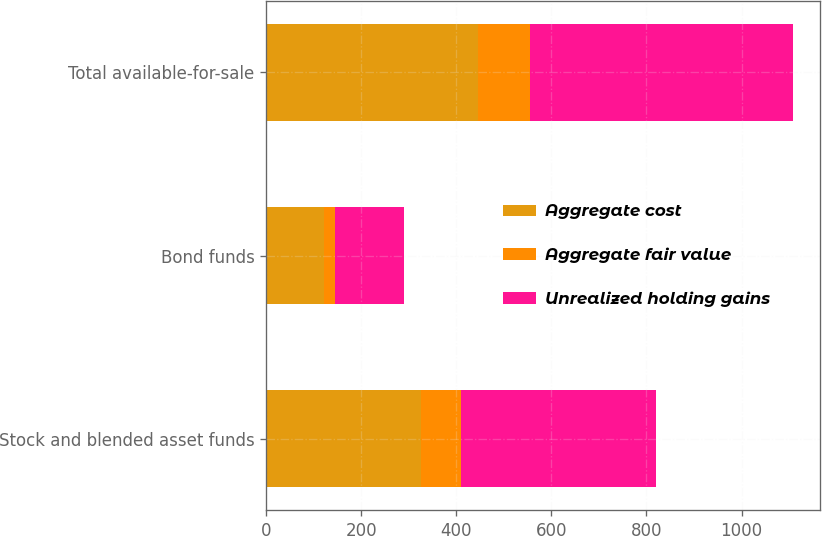Convert chart to OTSL. <chart><loc_0><loc_0><loc_500><loc_500><stacked_bar_chart><ecel><fcel>Stock and blended asset funds<fcel>Bond funds<fcel>Total available-for-sale<nl><fcel>Aggregate cost<fcel>325.5<fcel>120.6<fcel>446.1<nl><fcel>Aggregate fair value<fcel>84.3<fcel>24<fcel>108.3<nl><fcel>Unrealized holding gains<fcel>409.8<fcel>144.6<fcel>554.4<nl></chart> 